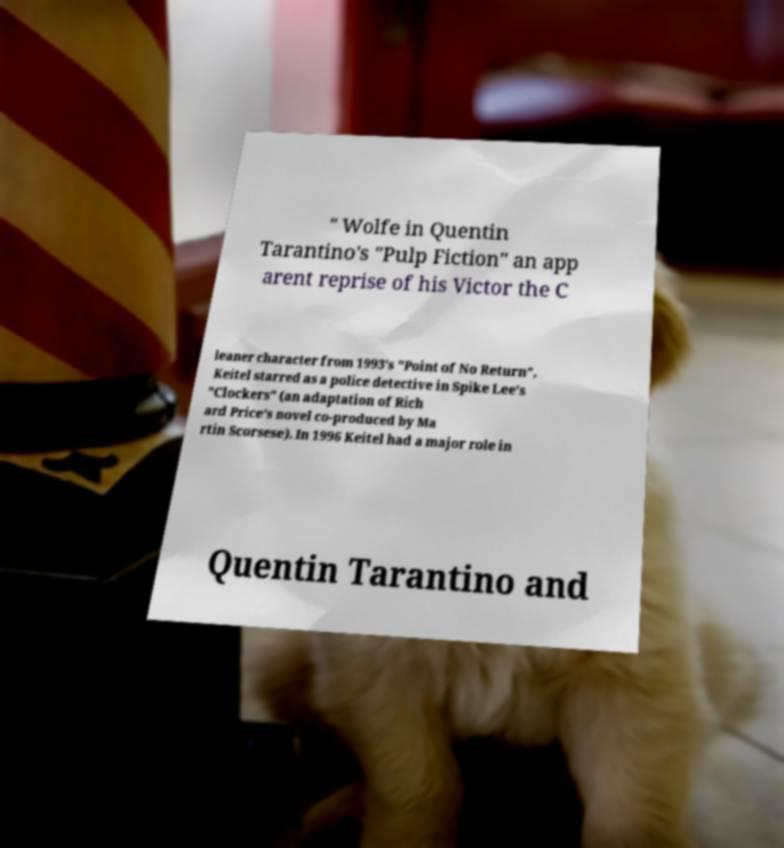Can you accurately transcribe the text from the provided image for me? " Wolfe in Quentin Tarantino's "Pulp Fiction" an app arent reprise of his Victor the C leaner character from 1993's "Point of No Return". Keitel starred as a police detective in Spike Lee's "Clockers" (an adaptation of Rich ard Price's novel co-produced by Ma rtin Scorsese). In 1996 Keitel had a major role in Quentin Tarantino and 